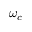Convert formula to latex. <formula><loc_0><loc_0><loc_500><loc_500>\omega _ { c }</formula> 